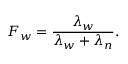Convert formula to latex. <formula><loc_0><loc_0><loc_500><loc_500>F _ { w } = \frac { \lambda _ { w } } { \lambda _ { w } + \lambda _ { n } } .</formula> 